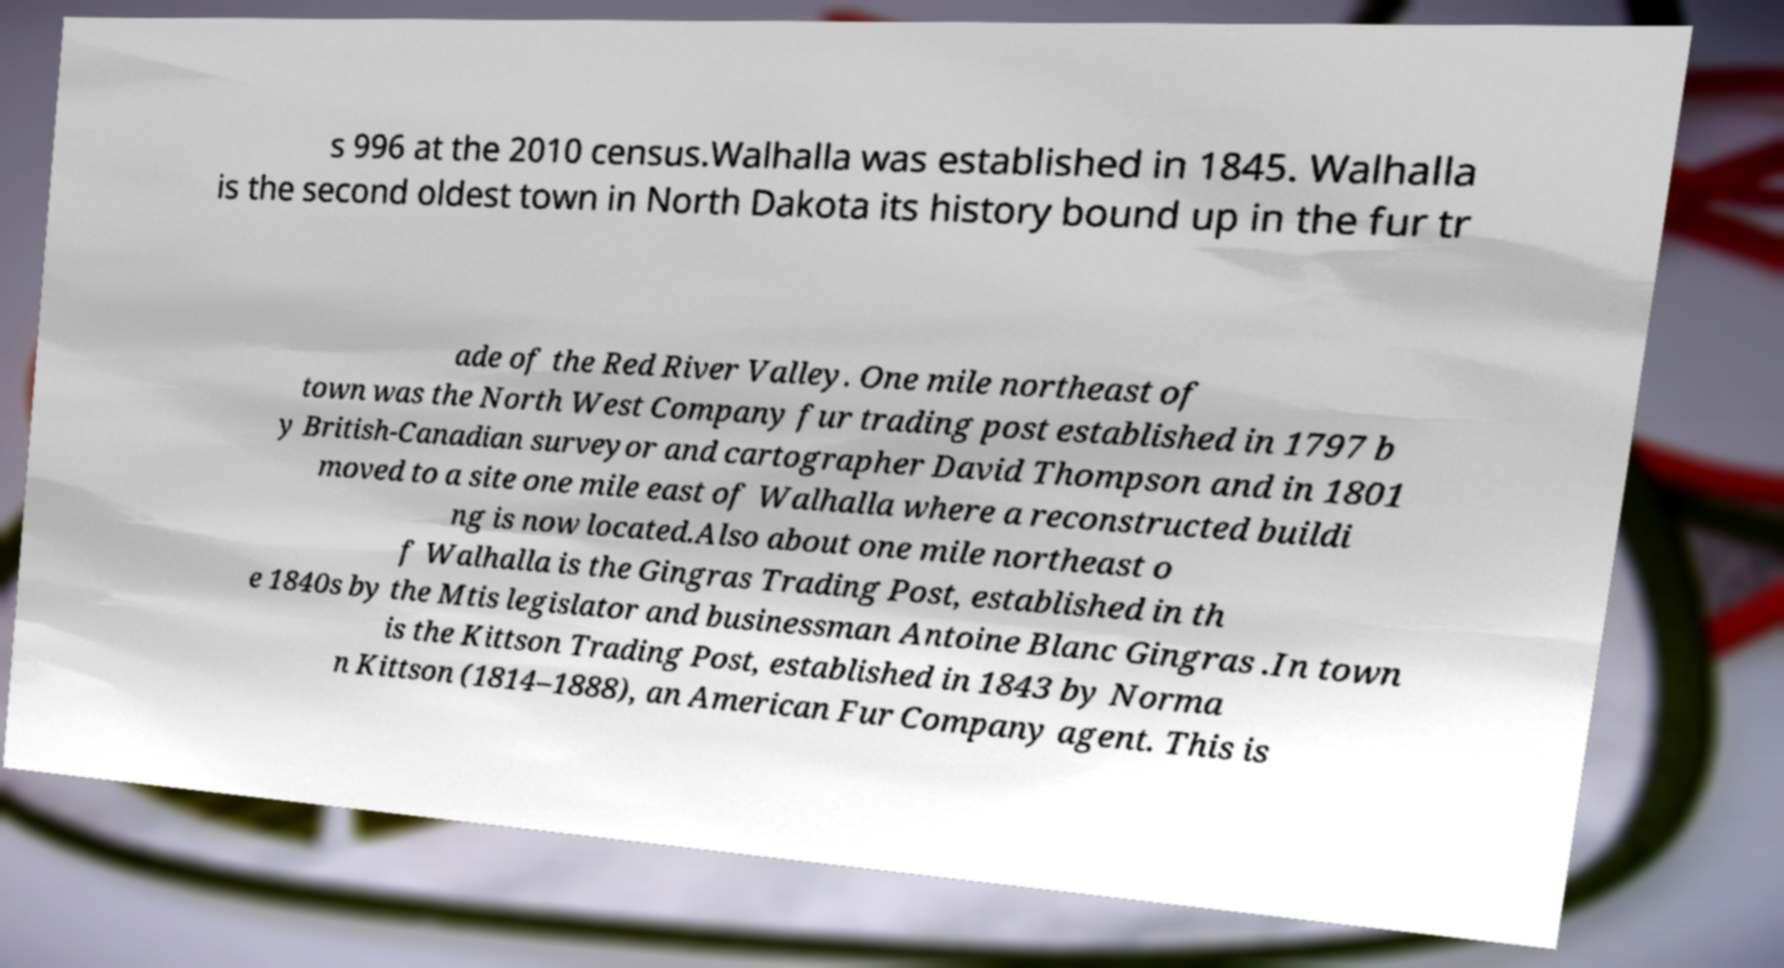Please identify and transcribe the text found in this image. s 996 at the 2010 census.Walhalla was established in 1845. Walhalla is the second oldest town in North Dakota its history bound up in the fur tr ade of the Red River Valley. One mile northeast of town was the North West Company fur trading post established in 1797 b y British-Canadian surveyor and cartographer David Thompson and in 1801 moved to a site one mile east of Walhalla where a reconstructed buildi ng is now located.Also about one mile northeast o f Walhalla is the Gingras Trading Post, established in th e 1840s by the Mtis legislator and businessman Antoine Blanc Gingras .In town is the Kittson Trading Post, established in 1843 by Norma n Kittson (1814–1888), an American Fur Company agent. This is 